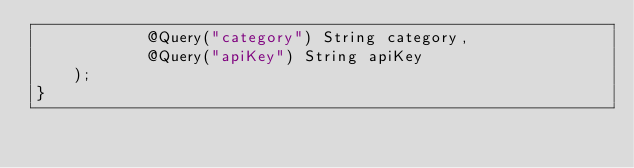Convert code to text. <code><loc_0><loc_0><loc_500><loc_500><_Java_>            @Query("category") String category,
            @Query("apiKey") String apiKey
    );
}</code> 